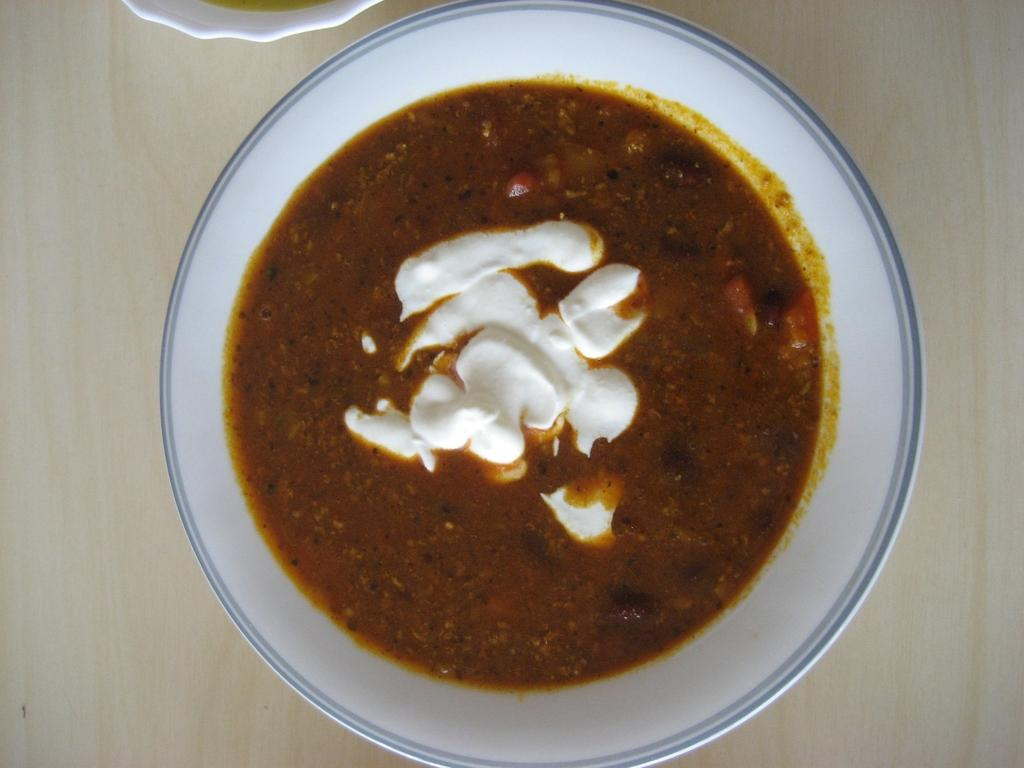What is present on the table in the image? There is a bowl and a cup on the table in the image. What is inside the bowl? There is a food item in the bowl. Can you describe the contents of the cup? The facts provided do not mention the contents of the cup. What type of twig is being used to push the food item in the bowl? There is no twig present in the image, and the food item is not being pushed. 